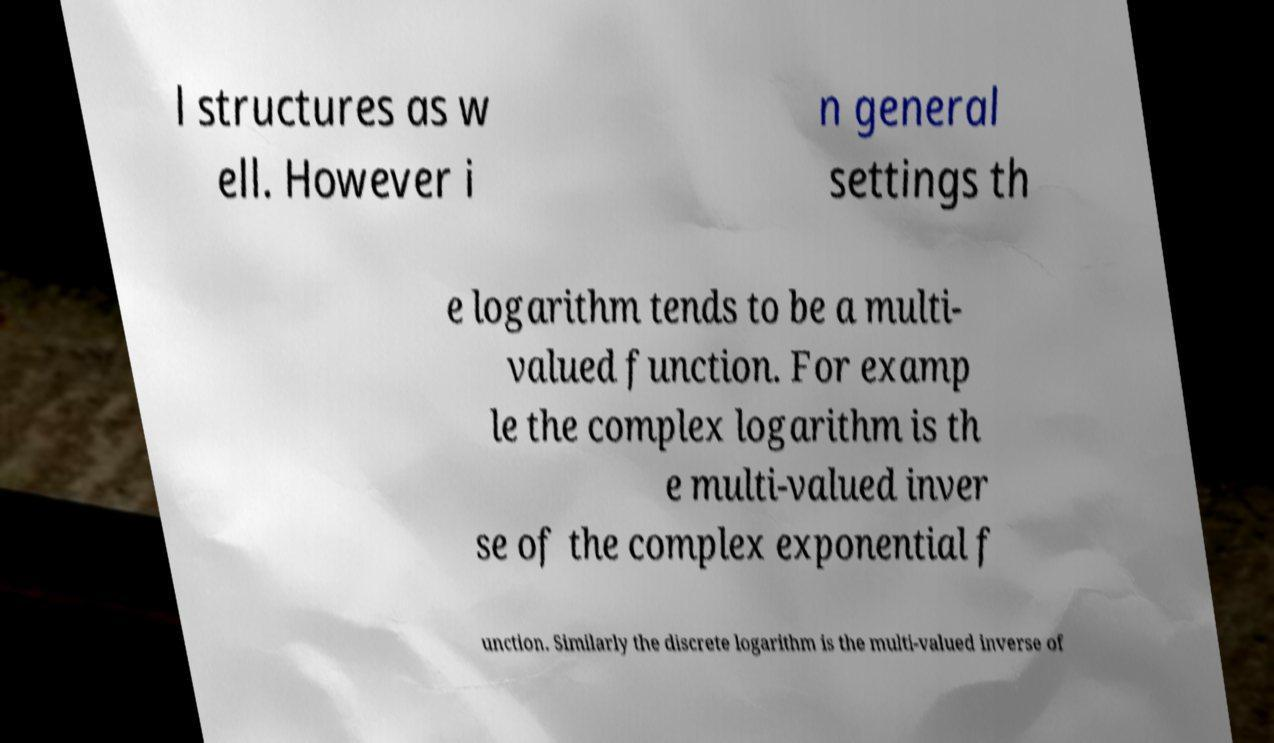Can you accurately transcribe the text from the provided image for me? l structures as w ell. However i n general settings th e logarithm tends to be a multi- valued function. For examp le the complex logarithm is th e multi-valued inver se of the complex exponential f unction. Similarly the discrete logarithm is the multi-valued inverse of 